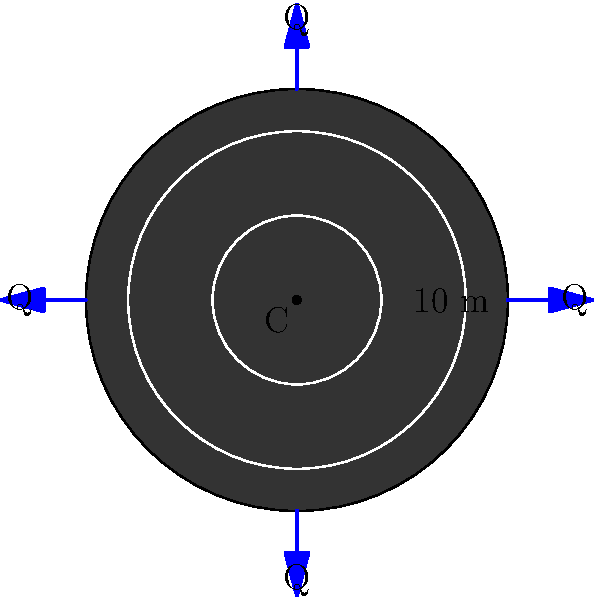A circular fountain shaped like a giant vinyl record has a diameter of 10 meters. Water jets out from four equally spaced points on the circumference, each with a flow rate of Q m³/s. If the water flows radially towards the center point C and then disappears through a drain, what is the velocity of the water at a distance of 1 meter from the center, assuming the depth of water remains constant throughout the fountain? Let's approach this step-by-step:

1) First, we need to understand that as the water moves towards the center, its velocity increases due to the conservation of mass (continuity equation).

2) The total flow rate entering the fountain is 4Q m³/s (Q from each of the four jets).

3) We can use the continuity equation: $Q = A_1v_1 = A_2v_2$, where A is the area and v is the velocity.

4) At any distance r from the center, the water is flowing through a circular path with circumference 2πr.

5) If the depth of water is h (constant), then the area at any radius r is $A = 2\pi r h$.

6) Let's call the velocity at 1 meter from the center v. Then:

   $4Q = (2\pi \cdot 5 \cdot h)(v_5) = (2\pi \cdot 1 \cdot h)(v)$

   where $v_5$ is the velocity at the edge (r = 5m).

7) From this, we can see that $5v_5 = v$.

8) Now, $4Q = 2\pi h \cdot 5v_5 = 2\pi h \cdot v$

9) Solving for v:

   $v = \frac{4Q}{2\pi h} = \frac{2Q}{\pi h}$

This is our final answer, expressing the velocity at 1 meter from the center in terms of Q and h.
Answer: $\frac{2Q}{\pi h}$ m/s 